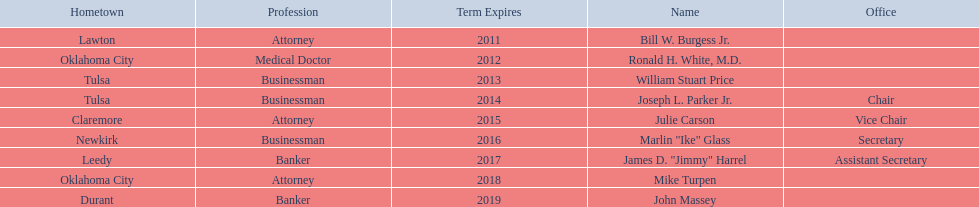What are all the names of oklahoma state regents for higher educations? Bill W. Burgess Jr., Ronald H. White, M.D., William Stuart Price, Joseph L. Parker Jr., Julie Carson, Marlin "Ike" Glass, James D. "Jimmy" Harrel, Mike Turpen, John Massey. Which ones are businessmen? William Stuart Price, Joseph L. Parker Jr., Marlin "Ike" Glass. Of those, who is from tulsa? William Stuart Price, Joseph L. Parker Jr. Whose term expires in 2014? Joseph L. Parker Jr. 